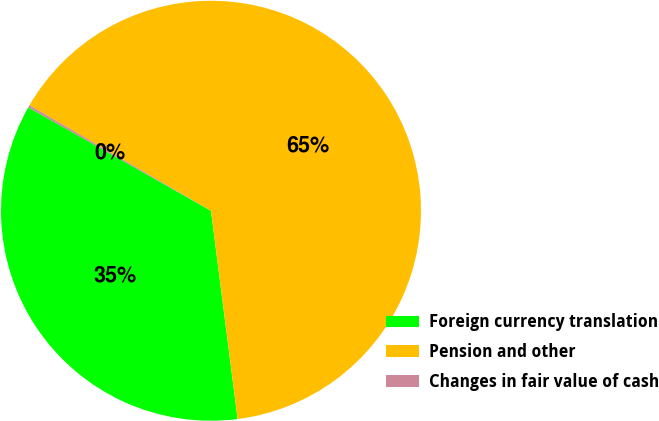Convert chart. <chart><loc_0><loc_0><loc_500><loc_500><pie_chart><fcel>Foreign currency translation<fcel>Pension and other<fcel>Changes in fair value of cash<nl><fcel>35.22%<fcel>64.6%<fcel>0.18%<nl></chart> 